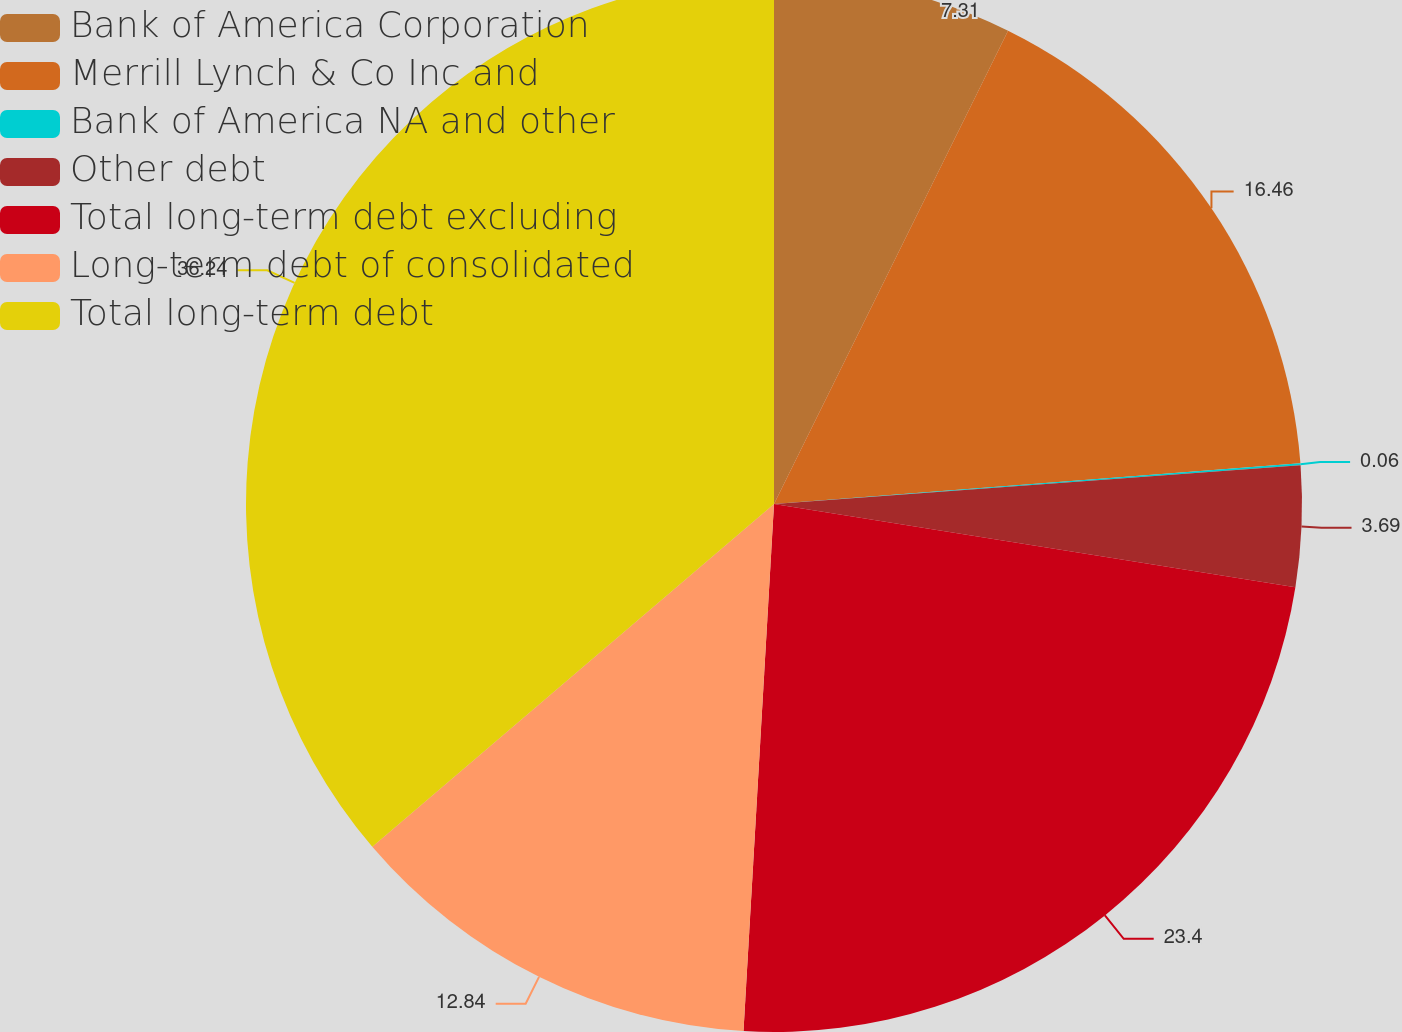Convert chart. <chart><loc_0><loc_0><loc_500><loc_500><pie_chart><fcel>Bank of America Corporation<fcel>Merrill Lynch & Co Inc and<fcel>Bank of America NA and other<fcel>Other debt<fcel>Total long-term debt excluding<fcel>Long-term debt of consolidated<fcel>Total long-term debt<nl><fcel>7.31%<fcel>16.46%<fcel>0.06%<fcel>3.69%<fcel>23.4%<fcel>12.84%<fcel>36.24%<nl></chart> 